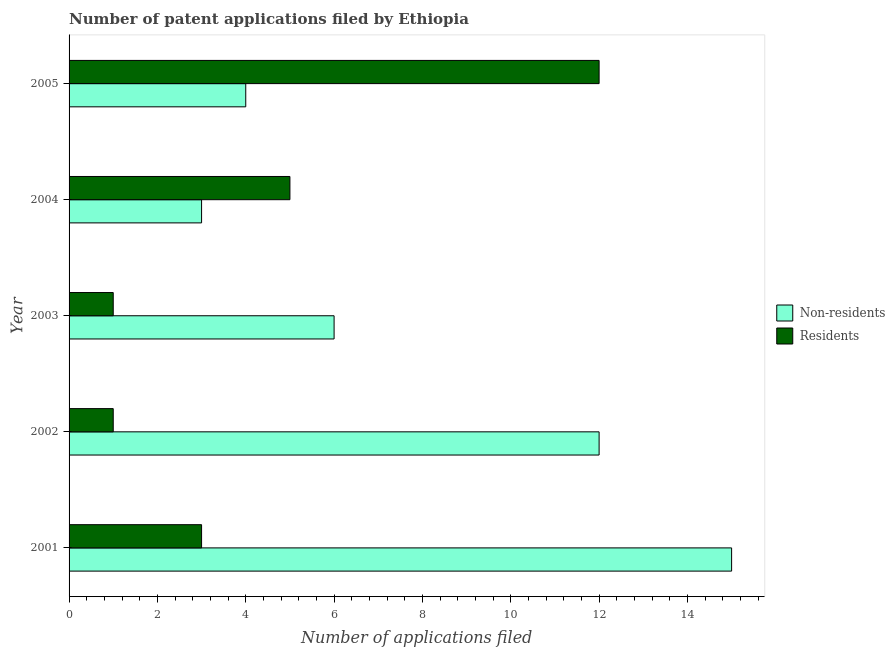Are the number of bars on each tick of the Y-axis equal?
Make the answer very short. Yes. How many bars are there on the 3rd tick from the top?
Your answer should be compact. 2. How many bars are there on the 4th tick from the bottom?
Give a very brief answer. 2. What is the label of the 1st group of bars from the top?
Give a very brief answer. 2005. What is the number of patent applications by residents in 2003?
Your answer should be compact. 1. Across all years, what is the maximum number of patent applications by residents?
Keep it short and to the point. 12. Across all years, what is the minimum number of patent applications by residents?
Offer a terse response. 1. What is the total number of patent applications by residents in the graph?
Provide a short and direct response. 22. What is the difference between the number of patent applications by residents in 2003 and that in 2005?
Your answer should be very brief. -11. What is the difference between the number of patent applications by non residents in 2003 and the number of patent applications by residents in 2002?
Provide a succinct answer. 5. In the year 2003, what is the difference between the number of patent applications by residents and number of patent applications by non residents?
Give a very brief answer. -5. In how many years, is the number of patent applications by residents greater than 9.2 ?
Give a very brief answer. 1. What is the ratio of the number of patent applications by residents in 2002 to that in 2005?
Your answer should be very brief. 0.08. Is the difference between the number of patent applications by non residents in 2001 and 2002 greater than the difference between the number of patent applications by residents in 2001 and 2002?
Keep it short and to the point. Yes. What is the difference between the highest and the lowest number of patent applications by residents?
Provide a succinct answer. 11. What does the 1st bar from the top in 2003 represents?
Your response must be concise. Residents. What does the 1st bar from the bottom in 2001 represents?
Your response must be concise. Non-residents. How many years are there in the graph?
Offer a terse response. 5. Are the values on the major ticks of X-axis written in scientific E-notation?
Your response must be concise. No. Does the graph contain any zero values?
Provide a short and direct response. No. Where does the legend appear in the graph?
Your response must be concise. Center right. How many legend labels are there?
Ensure brevity in your answer.  2. How are the legend labels stacked?
Give a very brief answer. Vertical. What is the title of the graph?
Provide a succinct answer. Number of patent applications filed by Ethiopia. Does "Pregnant women" appear as one of the legend labels in the graph?
Keep it short and to the point. No. What is the label or title of the X-axis?
Offer a terse response. Number of applications filed. What is the Number of applications filed of Non-residents in 2001?
Provide a succinct answer. 15. What is the Number of applications filed in Non-residents in 2004?
Your response must be concise. 3. What is the Number of applications filed in Non-residents in 2005?
Make the answer very short. 4. Across all years, what is the maximum Number of applications filed of Non-residents?
Your answer should be compact. 15. What is the total Number of applications filed in Non-residents in the graph?
Your answer should be compact. 40. What is the total Number of applications filed in Residents in the graph?
Give a very brief answer. 22. What is the difference between the Number of applications filed of Non-residents in 2001 and that in 2002?
Offer a terse response. 3. What is the difference between the Number of applications filed in Non-residents in 2001 and that in 2003?
Make the answer very short. 9. What is the difference between the Number of applications filed of Residents in 2001 and that in 2003?
Your response must be concise. 2. What is the difference between the Number of applications filed of Non-residents in 2001 and that in 2005?
Provide a succinct answer. 11. What is the difference between the Number of applications filed in Residents in 2001 and that in 2005?
Give a very brief answer. -9. What is the difference between the Number of applications filed of Residents in 2002 and that in 2003?
Offer a terse response. 0. What is the difference between the Number of applications filed in Residents in 2002 and that in 2004?
Provide a succinct answer. -4. What is the difference between the Number of applications filed in Non-residents in 2002 and that in 2005?
Give a very brief answer. 8. What is the difference between the Number of applications filed in Non-residents in 2003 and that in 2005?
Provide a short and direct response. 2. What is the difference between the Number of applications filed of Non-residents in 2004 and that in 2005?
Keep it short and to the point. -1. What is the difference between the Number of applications filed of Residents in 2004 and that in 2005?
Provide a short and direct response. -7. What is the difference between the Number of applications filed in Non-residents in 2001 and the Number of applications filed in Residents in 2004?
Your answer should be compact. 10. What is the difference between the Number of applications filed in Non-residents in 2002 and the Number of applications filed in Residents in 2003?
Provide a short and direct response. 11. What is the difference between the Number of applications filed of Non-residents in 2002 and the Number of applications filed of Residents in 2004?
Your answer should be compact. 7. What is the difference between the Number of applications filed of Non-residents in 2002 and the Number of applications filed of Residents in 2005?
Your answer should be compact. 0. What is the average Number of applications filed of Non-residents per year?
Provide a short and direct response. 8. What is the ratio of the Number of applications filed in Non-residents in 2001 to that in 2002?
Provide a short and direct response. 1.25. What is the ratio of the Number of applications filed in Residents in 2001 to that in 2002?
Ensure brevity in your answer.  3. What is the ratio of the Number of applications filed of Residents in 2001 to that in 2003?
Provide a succinct answer. 3. What is the ratio of the Number of applications filed of Residents in 2001 to that in 2004?
Make the answer very short. 0.6. What is the ratio of the Number of applications filed of Non-residents in 2001 to that in 2005?
Ensure brevity in your answer.  3.75. What is the ratio of the Number of applications filed in Residents in 2001 to that in 2005?
Keep it short and to the point. 0.25. What is the ratio of the Number of applications filed of Non-residents in 2002 to that in 2003?
Offer a terse response. 2. What is the ratio of the Number of applications filed of Non-residents in 2002 to that in 2004?
Offer a very short reply. 4. What is the ratio of the Number of applications filed in Residents in 2002 to that in 2005?
Keep it short and to the point. 0.08. What is the ratio of the Number of applications filed in Residents in 2003 to that in 2005?
Make the answer very short. 0.08. What is the ratio of the Number of applications filed in Residents in 2004 to that in 2005?
Give a very brief answer. 0.42. What is the difference between the highest and the second highest Number of applications filed in Residents?
Your response must be concise. 7. What is the difference between the highest and the lowest Number of applications filed in Residents?
Offer a very short reply. 11. 